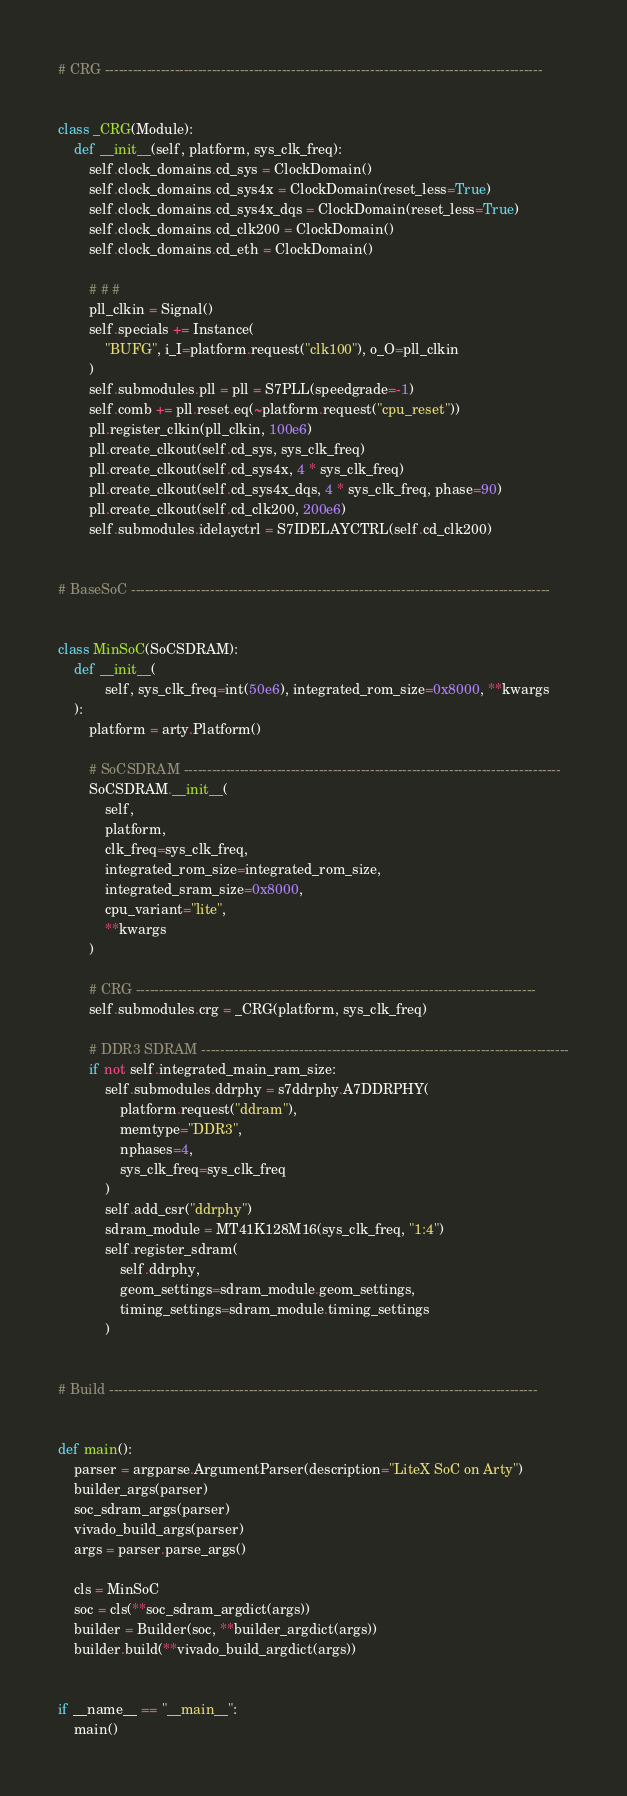Convert code to text. <code><loc_0><loc_0><loc_500><loc_500><_Python_>
# CRG ----------------------------------------------------------------------------------------------


class _CRG(Module):
    def __init__(self, platform, sys_clk_freq):
        self.clock_domains.cd_sys = ClockDomain()
        self.clock_domains.cd_sys4x = ClockDomain(reset_less=True)
        self.clock_domains.cd_sys4x_dqs = ClockDomain(reset_less=True)
        self.clock_domains.cd_clk200 = ClockDomain()
        self.clock_domains.cd_eth = ClockDomain()

        # # #
        pll_clkin = Signal()
        self.specials += Instance(
            "BUFG", i_I=platform.request("clk100"), o_O=pll_clkin
        )
        self.submodules.pll = pll = S7PLL(speedgrade=-1)
        self.comb += pll.reset.eq(~platform.request("cpu_reset"))
        pll.register_clkin(pll_clkin, 100e6)
        pll.create_clkout(self.cd_sys, sys_clk_freq)
        pll.create_clkout(self.cd_sys4x, 4 * sys_clk_freq)
        pll.create_clkout(self.cd_sys4x_dqs, 4 * sys_clk_freq, phase=90)
        pll.create_clkout(self.cd_clk200, 200e6)
        self.submodules.idelayctrl = S7IDELAYCTRL(self.cd_clk200)


# BaseSoC ------------------------------------------------------------------------------------------


class MinSoC(SoCSDRAM):
    def __init__(
            self, sys_clk_freq=int(50e6), integrated_rom_size=0x8000, **kwargs
    ):
        platform = arty.Platform()

        # SoCSDRAM ---------------------------------------------------------------------------------
        SoCSDRAM.__init__(
            self,
            platform,
            clk_freq=sys_clk_freq,
            integrated_rom_size=integrated_rom_size,
            integrated_sram_size=0x8000,
            cpu_variant="lite",
            **kwargs
        )

        # CRG --------------------------------------------------------------------------------------
        self.submodules.crg = _CRG(platform, sys_clk_freq)

        # DDR3 SDRAM -------------------------------------------------------------------------------
        if not self.integrated_main_ram_size:
            self.submodules.ddrphy = s7ddrphy.A7DDRPHY(
                platform.request("ddram"),
                memtype="DDR3",
                nphases=4,
                sys_clk_freq=sys_clk_freq
            )
            self.add_csr("ddrphy")
            sdram_module = MT41K128M16(sys_clk_freq, "1:4")
            self.register_sdram(
                self.ddrphy,
                geom_settings=sdram_module.geom_settings,
                timing_settings=sdram_module.timing_settings
            )


# Build --------------------------------------------------------------------------------------------


def main():
    parser = argparse.ArgumentParser(description="LiteX SoC on Arty")
    builder_args(parser)
    soc_sdram_args(parser)
    vivado_build_args(parser)
    args = parser.parse_args()

    cls = MinSoC
    soc = cls(**soc_sdram_argdict(args))
    builder = Builder(soc, **builder_argdict(args))
    builder.build(**vivado_build_argdict(args))


if __name__ == "__main__":
    main()
</code> 